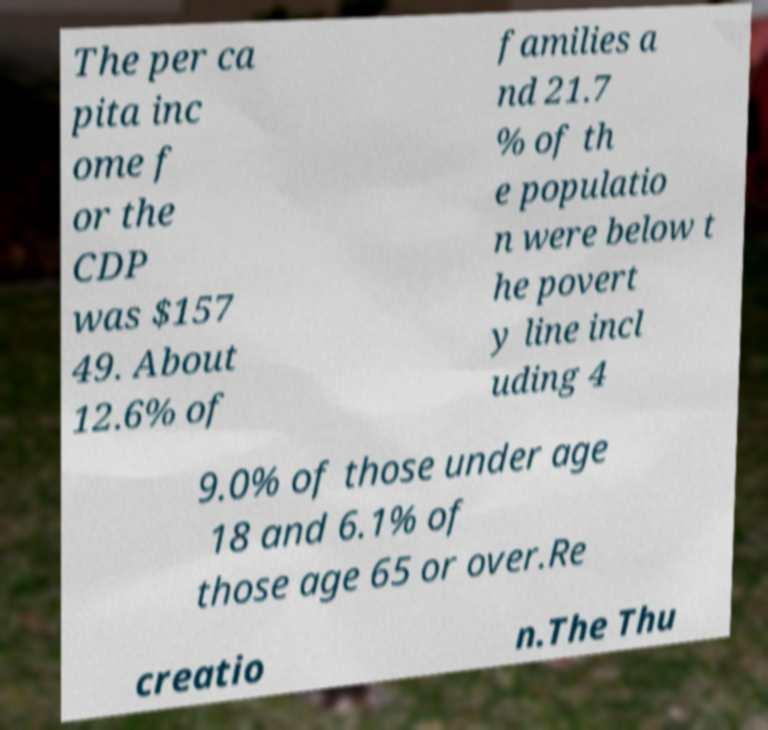Please identify and transcribe the text found in this image. The per ca pita inc ome f or the CDP was $157 49. About 12.6% of families a nd 21.7 % of th e populatio n were below t he povert y line incl uding 4 9.0% of those under age 18 and 6.1% of those age 65 or over.Re creatio n.The Thu 